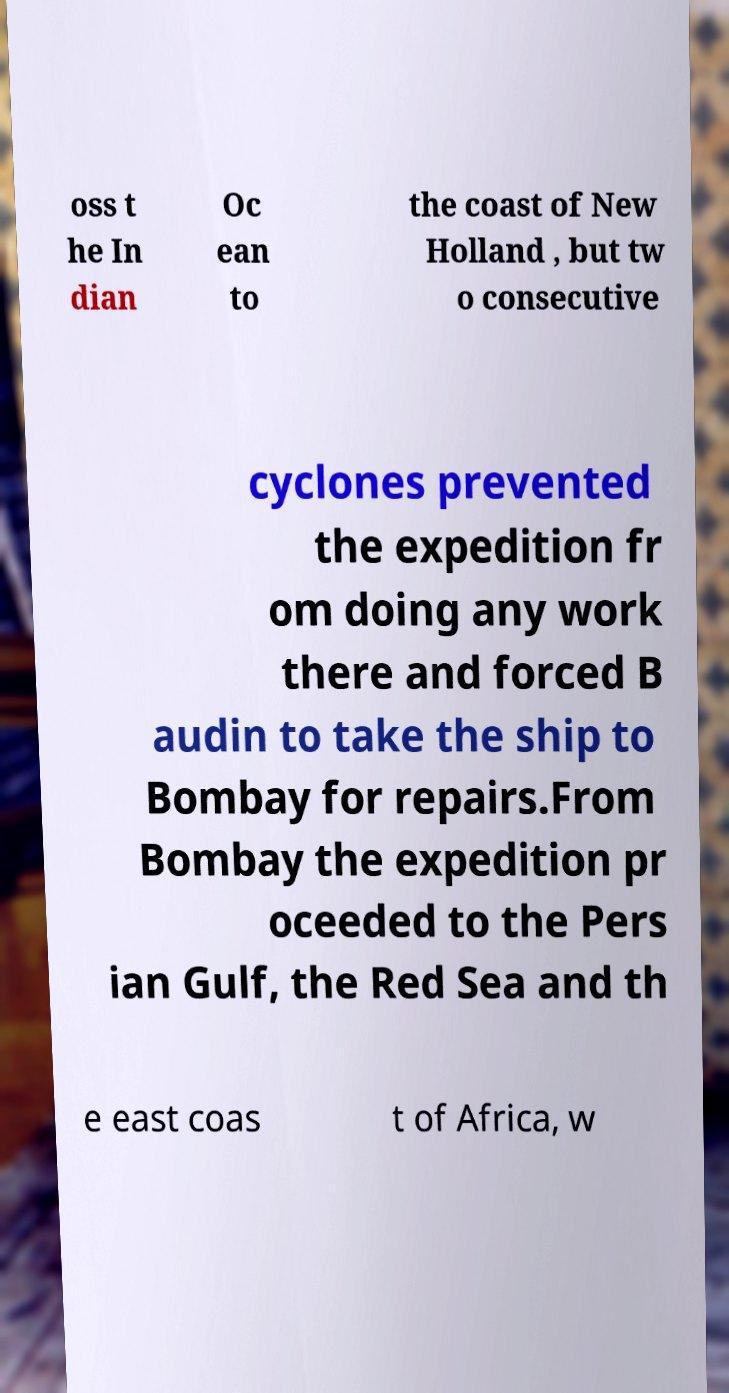Could you extract and type out the text from this image? oss t he In dian Oc ean to the coast of New Holland , but tw o consecutive cyclones prevented the expedition fr om doing any work there and forced B audin to take the ship to Bombay for repairs.From Bombay the expedition pr oceeded to the Pers ian Gulf, the Red Sea and th e east coas t of Africa, w 